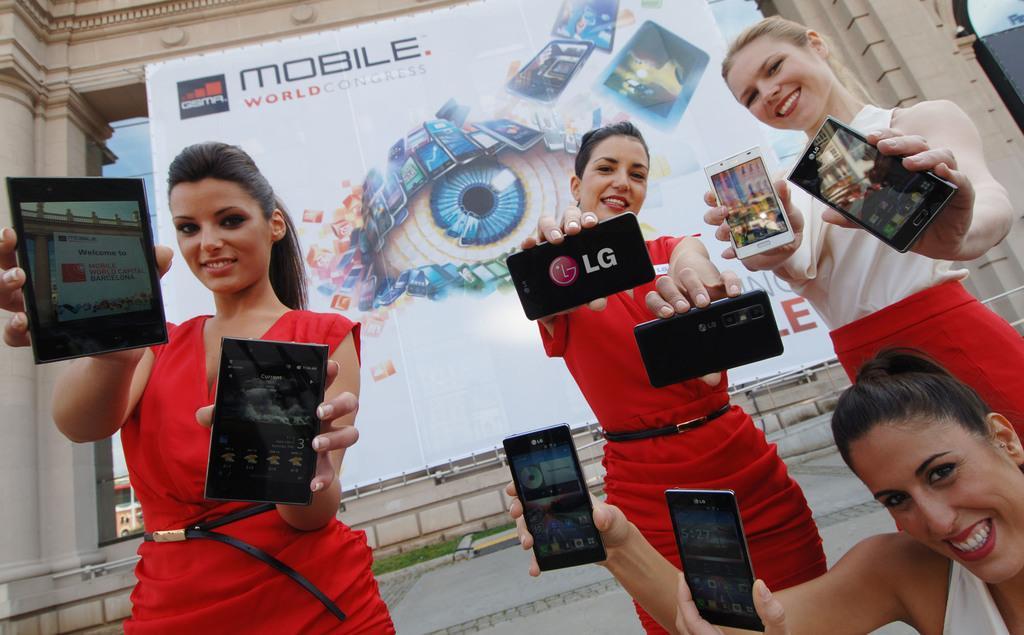How would you summarize this image in a sentence or two? In this image I can see four women are holding mobiles in their hands. This is an outside view. In the background I can see a building and a board is attached to the wall. 